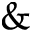<formula> <loc_0><loc_0><loc_500><loc_500>\&</formula> 